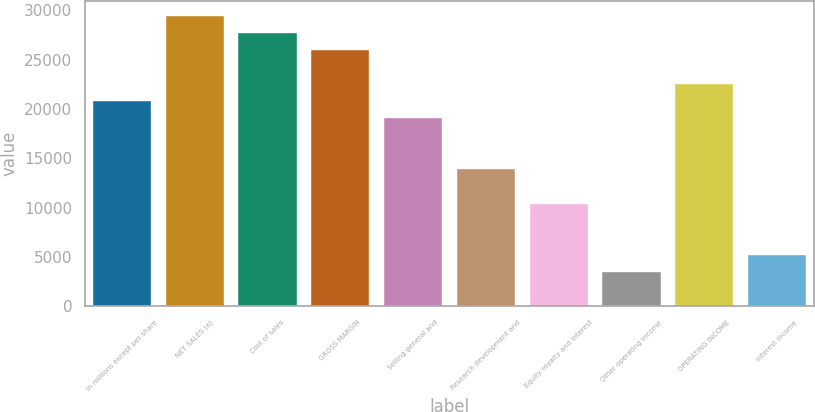Convert chart. <chart><loc_0><loc_0><loc_500><loc_500><bar_chart><fcel>In millions except per share<fcel>NET SALES (a)<fcel>Cost of sales<fcel>GROSS MARGIN<fcel>Selling general and<fcel>Research development and<fcel>Equity royalty and interest<fcel>Other operating income<fcel>OPERATING INCOME<fcel>Interest income<nl><fcel>20799<fcel>29461.7<fcel>27729.2<fcel>25996.6<fcel>19066.5<fcel>13868.9<fcel>10403.9<fcel>3473.73<fcel>22531.6<fcel>5206.26<nl></chart> 